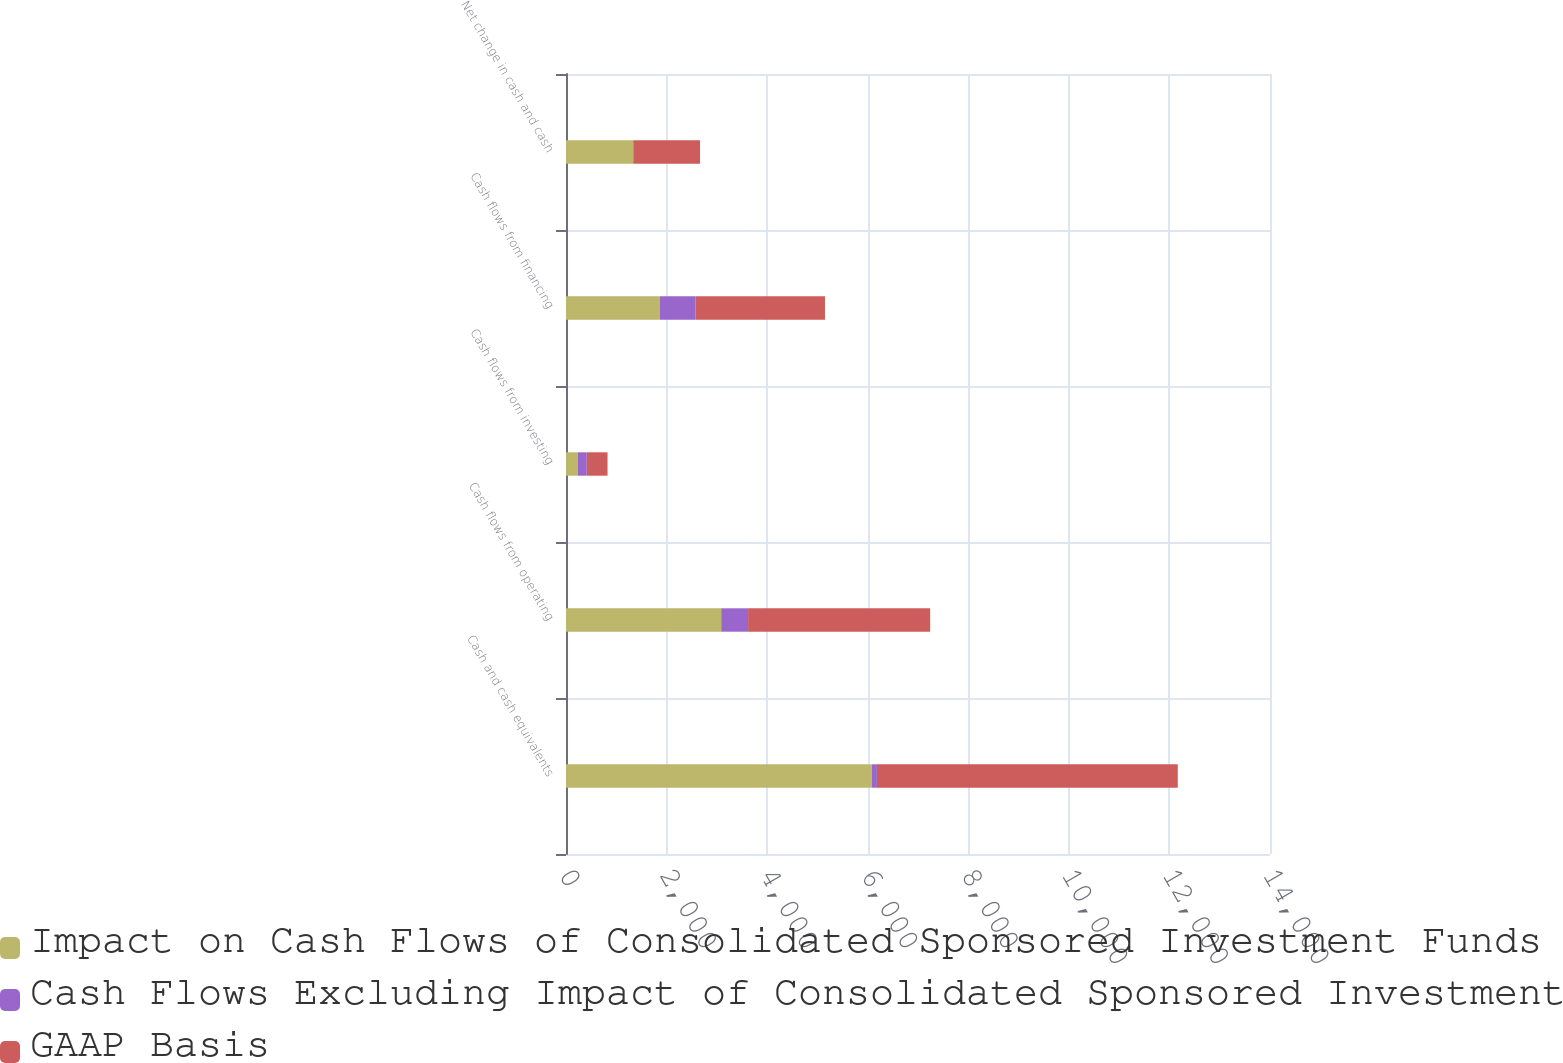Convert chart to OTSL. <chart><loc_0><loc_0><loc_500><loc_500><stacked_bar_chart><ecel><fcel>Cash and cash equivalents<fcel>Cash flows from operating<fcel>Cash flows from investing<fcel>Cash flows from financing<fcel>Net change in cash and cash<nl><fcel>Impact on Cash Flows of Consolidated Sponsored Investment Funds<fcel>6083<fcel>3087<fcel>239<fcel>1861<fcel>1333<nl><fcel>Cash Flows Excluding Impact of Consolidated Sponsored Investment Funds<fcel>100<fcel>534<fcel>174<fcel>714<fcel>6<nl><fcel>GAAP Basis<fcel>5983<fcel>3621<fcel>413<fcel>2575<fcel>1327<nl></chart> 